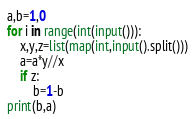<code> <loc_0><loc_0><loc_500><loc_500><_Python_>a,b=1,0
for i in range(int(input())):
    x,y,z=list(map(int,input().split()))
    a=a*y//x
    if z:
        b=1-b
print(b,a)</code> 